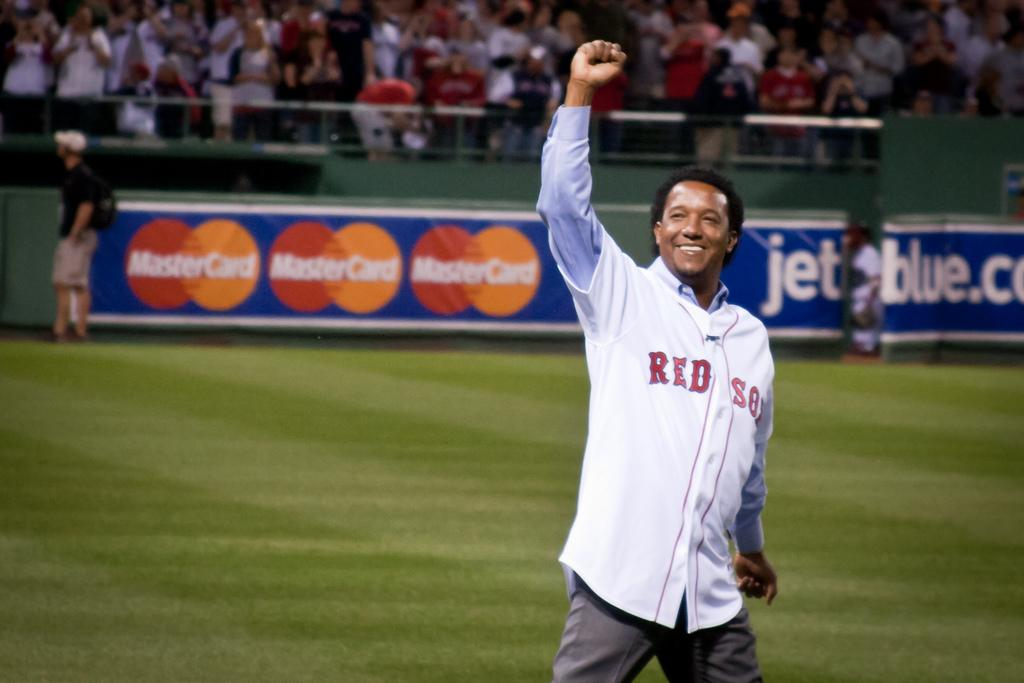Provide a one-sentence caption for the provided image. A man in a Red Sox jersey is standing on a baseball fiend with one arm raised in the air. 